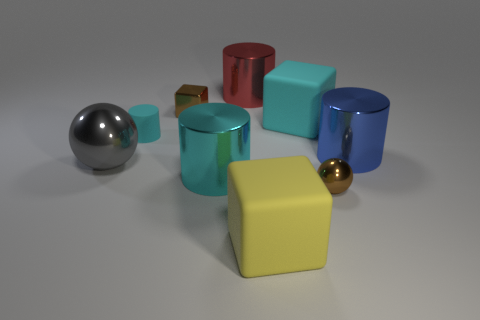Subtract all gray cylinders. Subtract all gray spheres. How many cylinders are left? 4 Add 1 small cyan matte cylinders. How many objects exist? 10 Subtract all cubes. How many objects are left? 6 Subtract 2 cyan cylinders. How many objects are left? 7 Subtract all big spheres. Subtract all brown cubes. How many objects are left? 7 Add 9 yellow rubber objects. How many yellow rubber objects are left? 10 Add 2 cyan rubber spheres. How many cyan rubber spheres exist? 2 